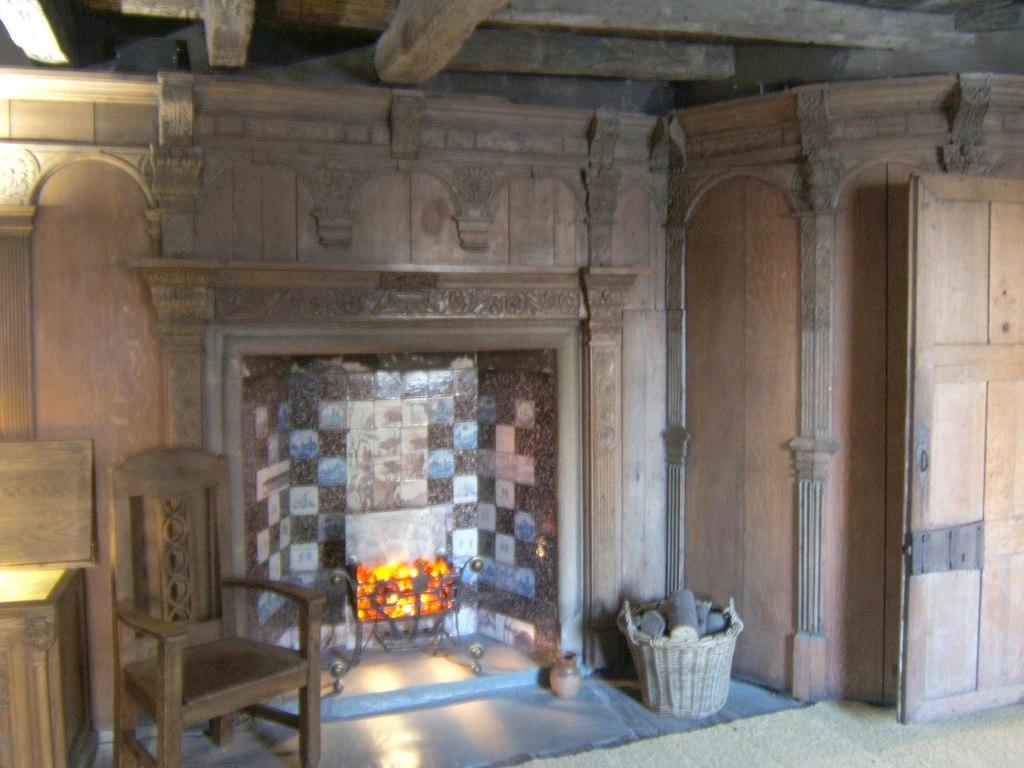What is the main feature in the center of the image? There is a fireplace in the center of the image. What can be seen on the left side of the image? There is a table and a chair on the left side of the image. What is located on the right side of the image? There is a basket and a door on the right side of the image. What type of ball is being used to answer questions in the image? There is no ball or question-answering activity present in the image. Can you tell me how many people are getting a haircut in the image? There is no haircut or person getting a haircut depicted in the image. 